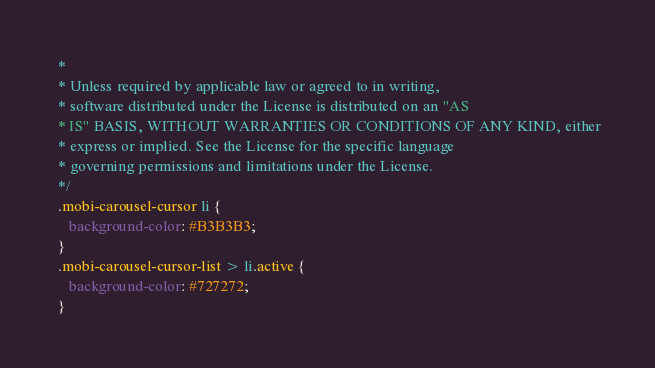<code> <loc_0><loc_0><loc_500><loc_500><_CSS_> *
 * Unless required by applicable law or agreed to in writing,
 * software distributed under the License is distributed on an "AS
 * IS" BASIS, WITHOUT WARRANTIES OR CONDITIONS OF ANY KIND, either
 * express or implied. See the License for the specific language
 * governing permissions and limitations under the License.
 */
 .mobi-carousel-cursor li {
    background-color: #B3B3B3;
 }
 .mobi-carousel-cursor-list > li.active { 
    background-color: #727272;
 }</code> 